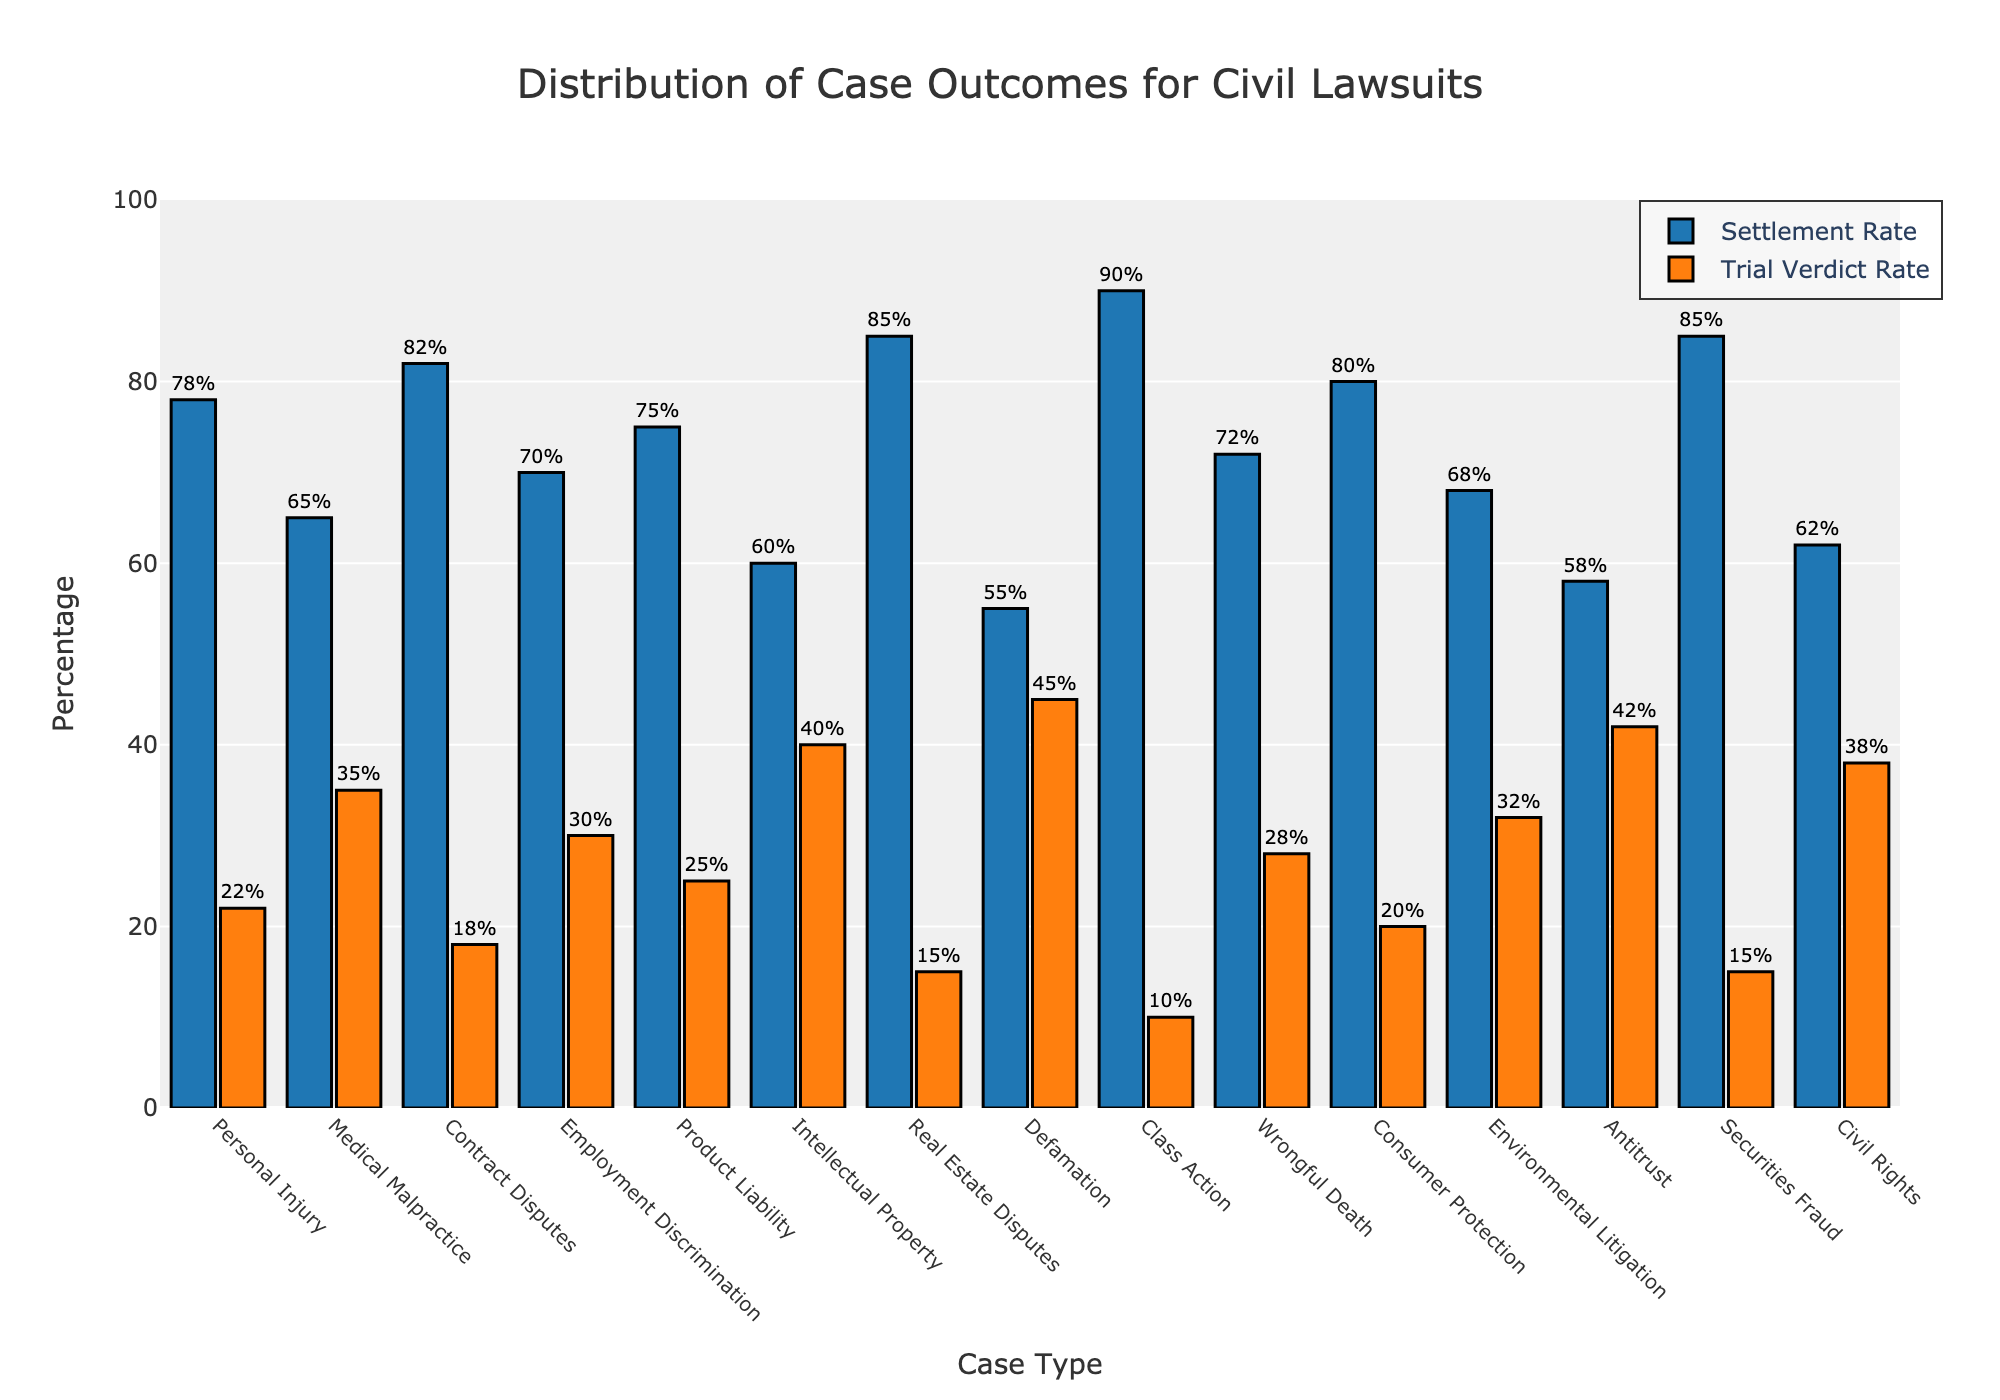Which case type has the highest settlement rate? Look for the tallest blue bar, which represents the highest settlement rate. The tallest blue bar corresponds to Class Action disputes with a settlement rate of 90%.
Answer: Class Action Which case type has the highest trial verdict rate? Identify the tallest orange bar, which indicates the highest trial verdict rate. The tallest orange bar corresponds to Defamation with a trial verdict rate of 45%.
Answer: Defamation What's the difference in settlement rates between Intellectual Property and Antitrust cases? Subtract the settlement rate of Antitrust (58%) from the settlement rate of Intellectual Property (60%). The difference is 60% - 58% = 2%.
Answer: 2% Which case type has a settlement rate equal to 70%? Find the blue bar that reaches the 70% mark on the y-axis. This corresponds to Employment Discrimination cases, which have a settlement rate of 70%.
Answer: Employment Discrimination Compare the settlement and trial verdict rates for Medical Malpractice cases. Look at the blue and orange bars for Medical Malpractice. The blue bar (settlement rate) is at 65%, and the orange bar (trial verdict rate) is at 35%. The settlement rate is higher by 65% - 35% = 30%.
Answer: Settlement rate is higher by 30% Which case types have trial verdict rates higher than 30%? Identify the case types with orange bars exceeding the 30% mark on the y-axis. These case types include Medical Malpractice (35%), Employment Discrimination (30%), Defamation (45%), Environmental Litigation (32%), and Antitrust (42%).
Answer: Medical Malpractice, Defamation, Environmental Litigation, Antitrust What is the average settlement rate for Consumer Protection and Wrongful Death cases? Add the settlement rates for Consumer Protection (80%) and Wrongful Death (72%), then divide by 2. The average is (80% + 72%) / 2 = 76%.
Answer: 76% How does the settlement rate for Securities Fraud compare to that of Real Estate Disputes? Check the heights of the blue bars for both case types. The settlement rate for Securities Fraud is 85%, which is equal to the settlement rate for Real Estate Disputes, also 85%.
Answer: They are equal What is the total percentage of settlement and trial verdict rates for Contract Disputes? Add the settlement rate (82%) and trial verdict rate (18%) for Contract Disputes. The total is 82% + 18% = 100%.
Answer: 100% Which case types have settlement rates lower than 60%? Identify the case types with blue bars below the 60% mark. The case types are Defamation (55%) and Antitrust (58%).
Answer: Defamation, Antitrust 